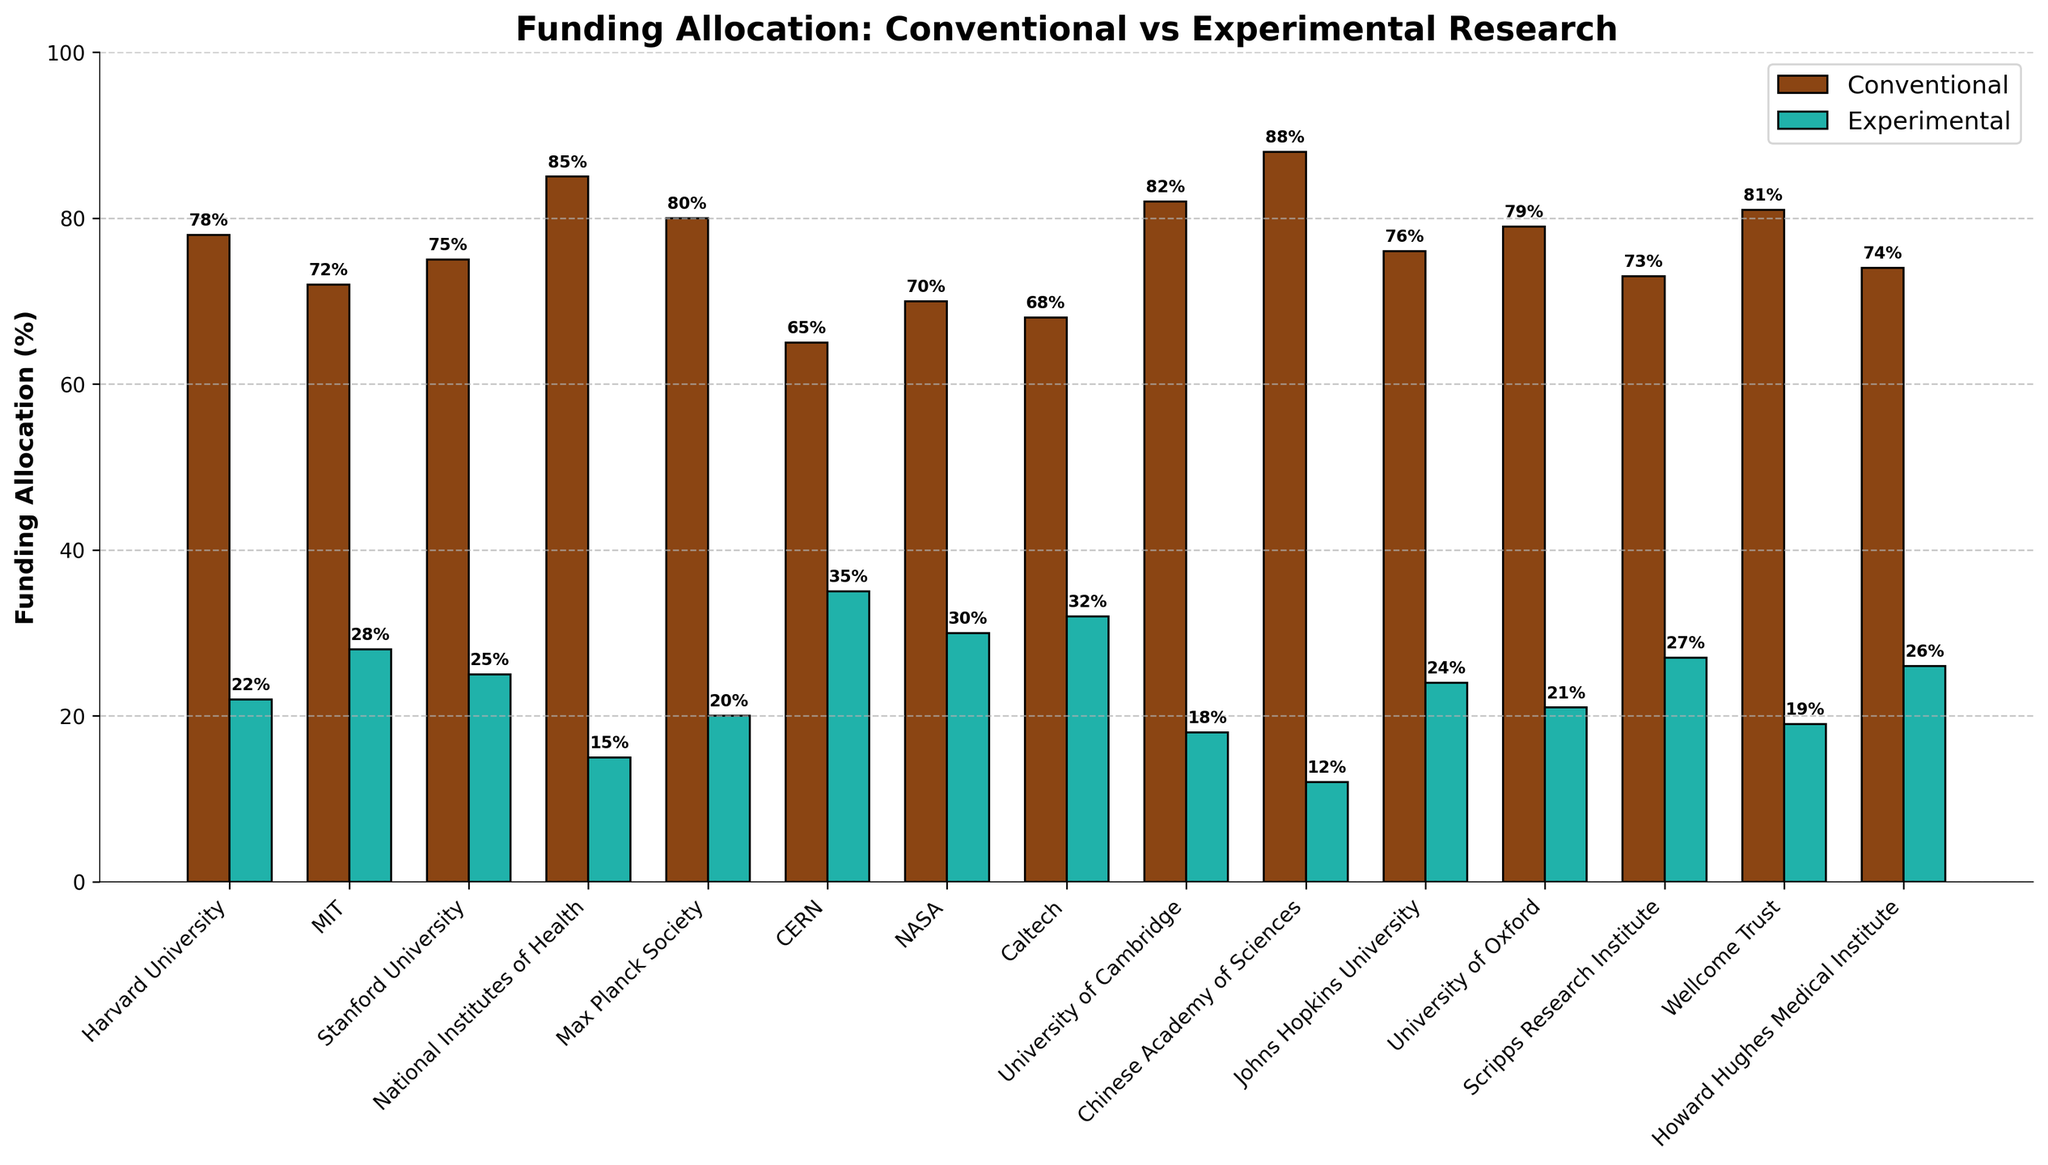What's the total funding allocation for experimental research across all institutions? First, sum the experimental funding percentages across all institutions: 22 + 28 + 25 + 15 + 20 + 35 + 30 + 32 + 18 + 12 + 24 + 21 + 27 + 19 + 26. The total is 334%.
Answer: 334% Which institution allocates the highest percentage of its funding to experimental research? Look at the heights of the bars for experimental funding. CERN has the tallest bar for experimental funding at 35%.
Answer: CERN Compare the funding allocation between conventional and experimental research at Harvard University. Which one is higher and by how much? At Harvard University, conventional funding is 78% and experimental funding is 22%. Subtract the experimental funding from the conventional funding: 78% - 22% = 56%. Conventional funding is 56% higher.
Answer: Conventional by 56% Which institution has the closest funding allocation between conventional and experimental research? Find the institution with the smallest difference between the two funding amounts by checking the bars. For NASA, conventional funding is 70% and experimental funding is 30%. The difference is 40%, which appears to be the smallest.
Answer: NASA What is the average funding percentage allocated to conventional research across all institutions? Sum the conventional funding percentages and divide by the number of institutions: (78 + 72 + 75 + 85 + 80 + 65 + 70 + 68 + 82 + 88 + 76 + 79 + 73 + 81 + 74) / 15 = 1096 / 15 ≈ 73.07%.
Answer: 73.07% How does the experimental funding at Max Planck Society compare to that at Wellcome Trust? Max Planck Society has an experimental funding of 20%, and Wellcome Trust has 19%. Max Planck Society has a 1% higher experimental funding than Wellcome Trust.
Answer: Max Planck Society by 1% Which institution has the highest total funding allocation (sum of conventional and experimental)? Calculate the total funding for each institution and find the highest: Harvard (100), MIT (100), Stanford (100), NIH (100), Max Planck (100), CERN (100), NASA (100), Caltech (100), Cambridge (100), CAS (100), Johns Hopkins (100), Oxford (100), Scripps (100), Wellcome Trust (100), Howard Hughes (100). All have equal total funding of 100%.
Answer: All institutions What's the range of conventional funding allocations? The lowest conventional funding is 65% (CERN) and the highest is 88% (Chinese Academy of Sciences). Range is 88% - 65% = 23%.
Answer: 23% Identify the institutions where the experimental research funding exceeds 25%. Scan the experimental funding bars and find those above 25%. Institutions are MIT (28%), Stanford (25%), CERN (35%), NASA (30%), Caltech (32%), Scripps (27%), HHMI (26%).
Answer: MIT, Stanford, CERN, NASA, Caltech, Scripps, Howard Hughes 